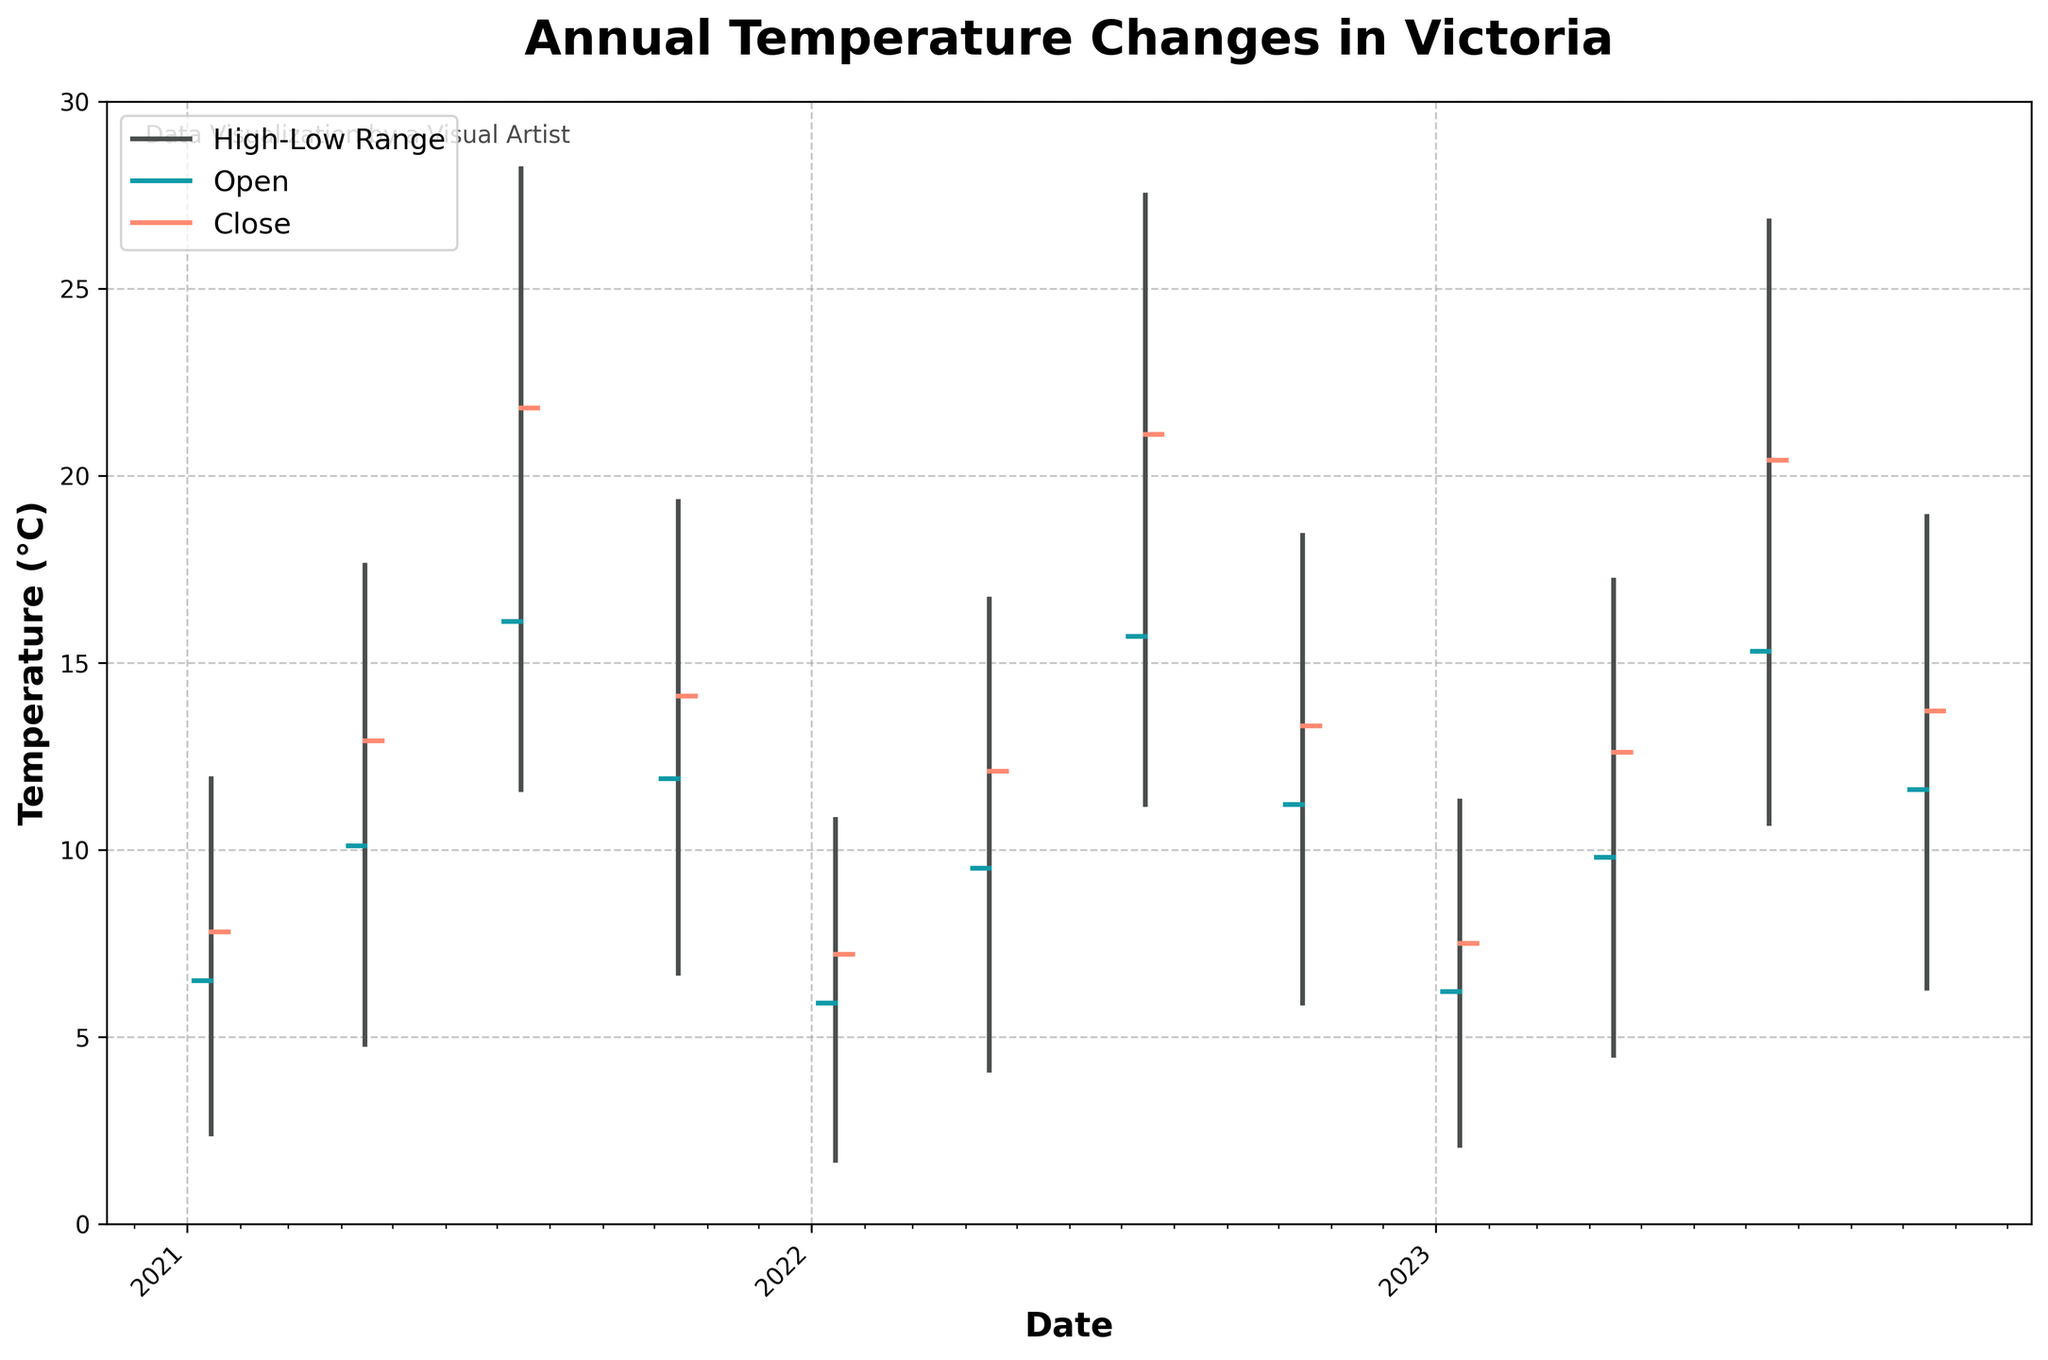What's the title of the figure? The title is located at the top of the figure in a noticeable font. Reading it, we see it is "Annual Temperature Changes in Victoria."
Answer: Annual Temperature Changes in Victoria What is the temperature range in July 2023? We look at the July 2023 data point, where the vertical line extends from the Low value to the High value. For July 2023, the Low is 10.7°C and the High is 26.8°C.
Answer: 10.7°C to 26.8°C Which month and year recorded the lowest High temperature? Observing the highest points of the vertical lines (representing the High temperatures), the lowest High is 10.8°C in January 2022.
Answer: January 2022 How many data points are plotted in the figure? Count the vertical lines representing different dates; each line corresponds to a data point. There are 12 dates in total.
Answer: 12 Between which years does the plot span? Observe the x-axis, which lists the years. It starts at 2021 and ends at 2023.
Answer: 2021 to 2023 Which day had the highest Open temperature and what was it? Look at the Open values marked on the left of each vertical line. The highest Open temperature is 16.1°C on July 15, 2021.
Answer: July 15, 2021, 16.1°C In which month and year was there the smallest difference between the High and Low temperatures? Calculate the differences between High and Low for each data point. The smallest difference is seen in January 2021, where it is 11.9 - 2.4 = 9.5°C.
Answer: January 2021 What is the average Close temperature for April across the years? Sum the Close temperatures for April (12.9°C in 2021, 12.1°C in 2022, 12.6°C in 2023) and divide by the number of data points (3). The average is (12.9 + 12.1 + 12.6) / 3 = 12.53°C.
Answer: 12.53°C How does the High temperature in October 2022 compare to the High temperature in October 2023? Look at the High temperatures for October in both years: October 2022 is 18.4°C, and October 2023 is 18.9°C. The High in October 2023 is slightly higher.
Answer: October 2023 is higher Which year had the highest Close temperature in July? Observe the Close temperatures for July. The highest Close temperature is 21.8°C in July 2021.
Answer: July 2021 